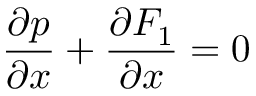Convert formula to latex. <formula><loc_0><loc_0><loc_500><loc_500>\frac { \partial p } { \partial x } + \frac { \partial F _ { 1 } } { \partial x } = 0</formula> 